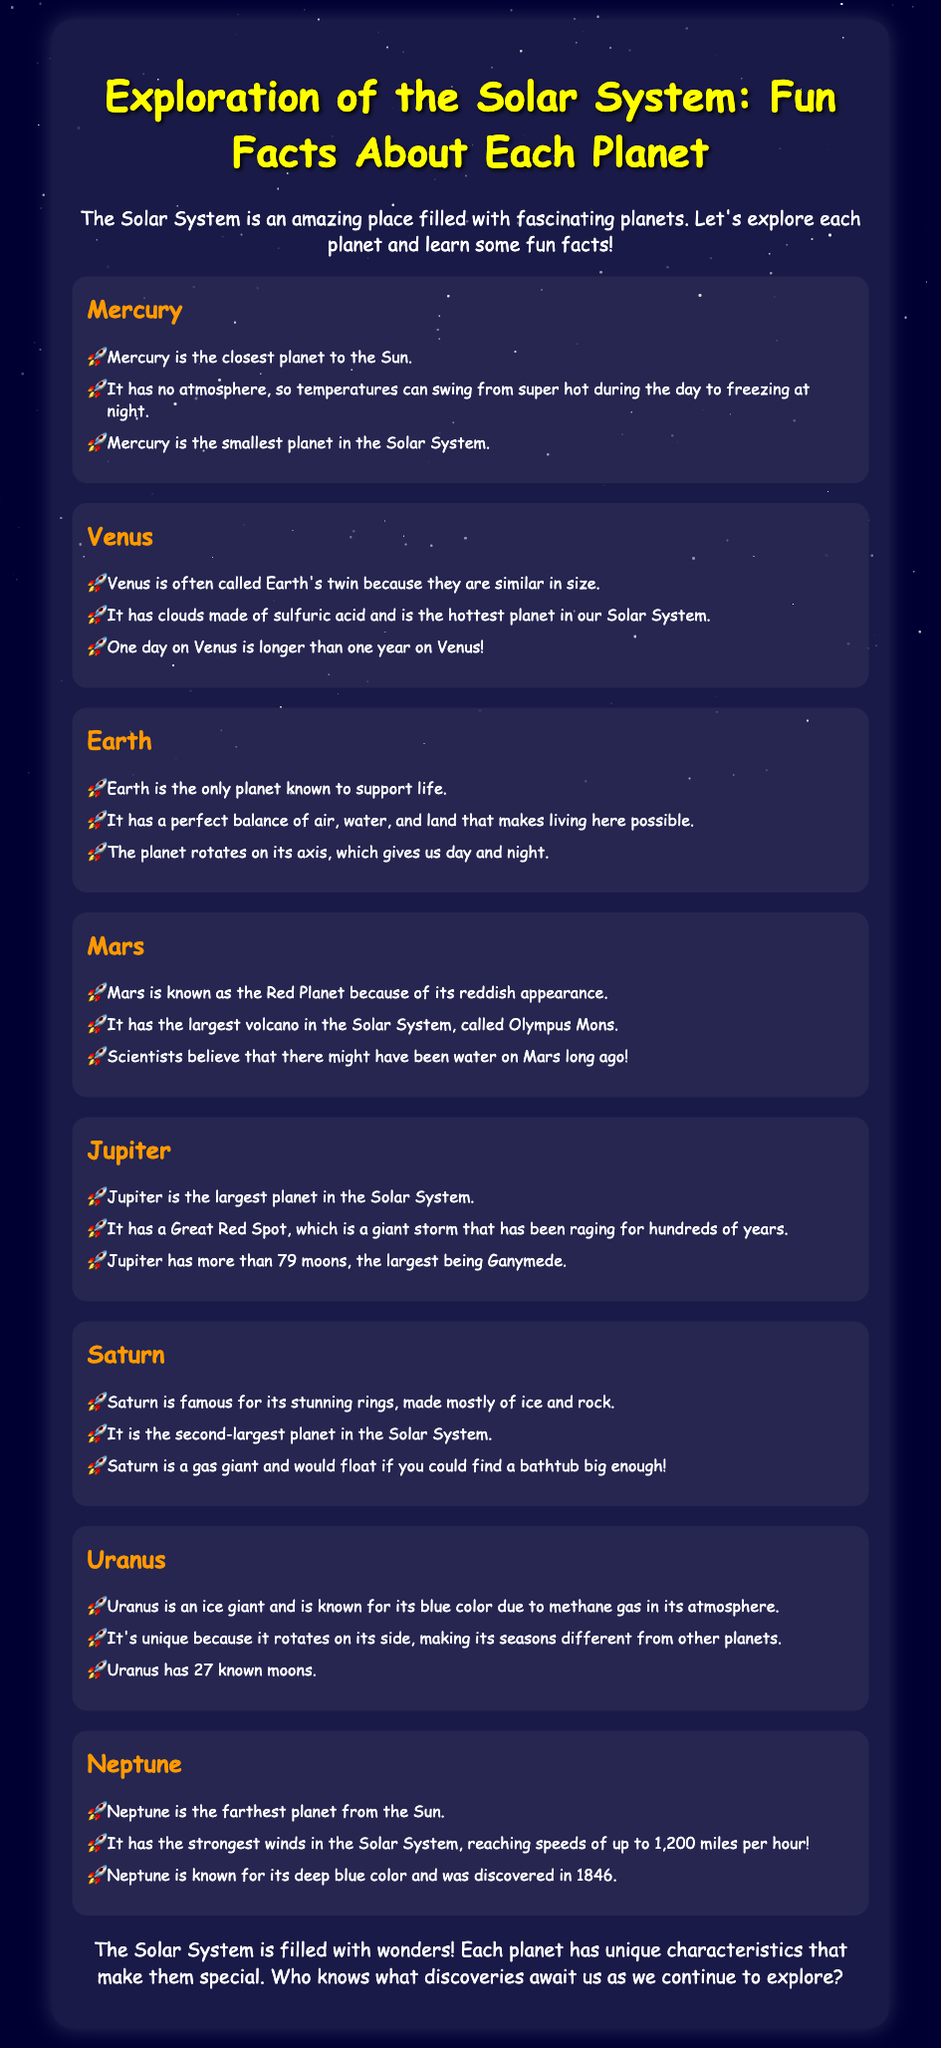What is the smallest planet in the Solar System? The document states that Mercury is the smallest planet.
Answer: Mercury Which planet is known as Earth's twin? The document mentions Venus as often being called Earth's twin.
Answer: Venus What is unique about a day on Venus compared to a year? According to the document, one day on Venus is longer than one year on Venus.
Answer: Longer What color is Uranus known for? The document explains that Uranus is known for its blue color.
Answer: Blue How many moons does Jupiter have? The document specifies that Jupiter has more than 79 moons.
Answer: More than 79 What is Saturn famous for? The document states that Saturn is famous for its stunning rings.
Answer: Stunning rings Which planet is furthest from the Sun? According to the document, Neptune is the farthest planet from the Sun.
Answer: Neptune What is the largest volcano in the Solar System? The document mentions Olympus Mons as the largest volcano on Mars.
Answer: Olympus Mons What gas causes the blue color of Uranus? The document states that methane gas in its atmosphere gives Uranus its blue color.
Answer: Methane gas 